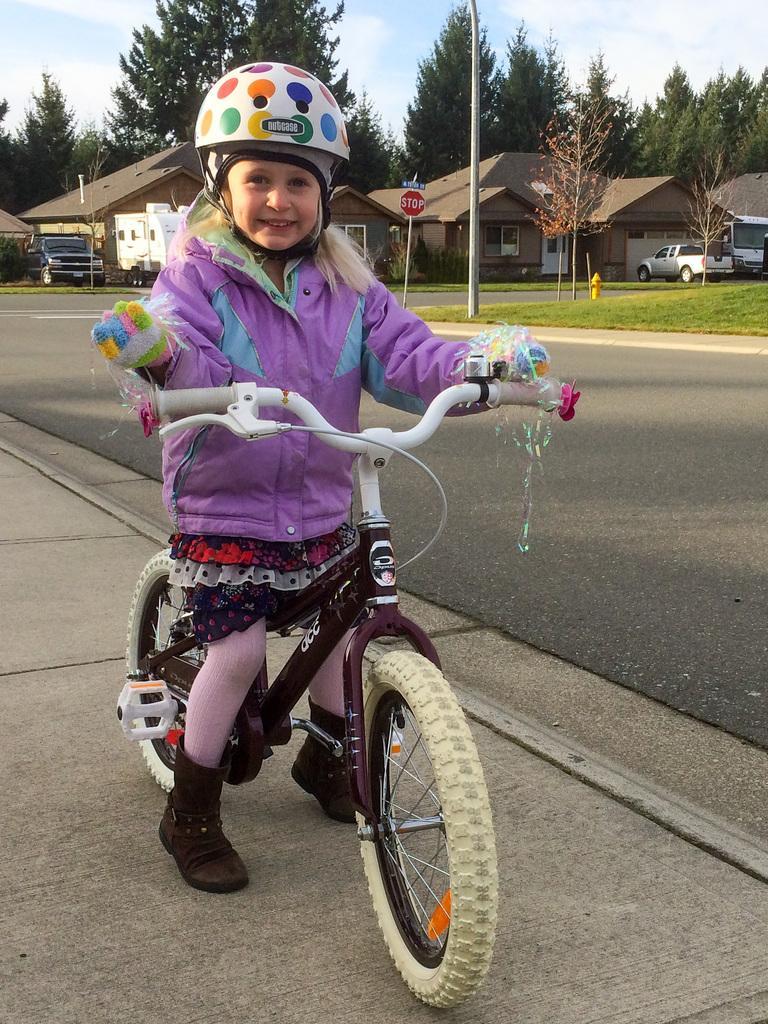Can you describe this image briefly? In the foreground of the picture we can see a girl on a bicycle and we can see footpath. In the middle it is road. In the background there are trees, buildings, cars, grass and road. At the top there is sky. 